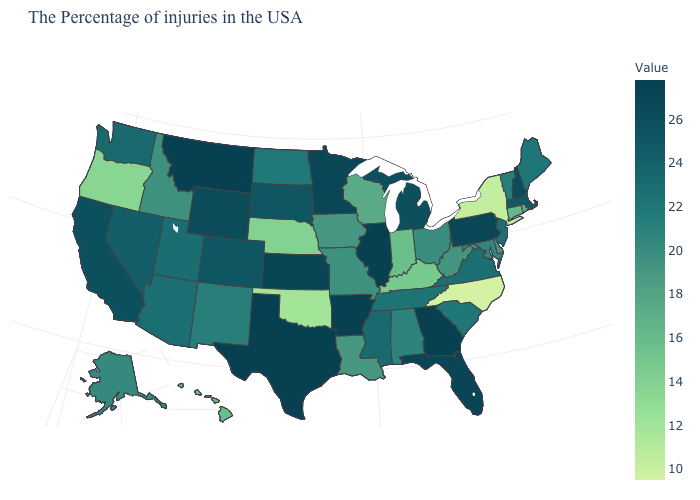Does Illinois have the highest value in the MidWest?
Be succinct. Yes. Among the states that border Maine , which have the lowest value?
Concise answer only. New Hampshire. Among the states that border Washington , which have the highest value?
Answer briefly. Idaho. Does Utah have the lowest value in the West?
Quick response, please. No. Which states have the highest value in the USA?
Quick response, please. Georgia, Illinois, Arkansas, Texas, Montana. 